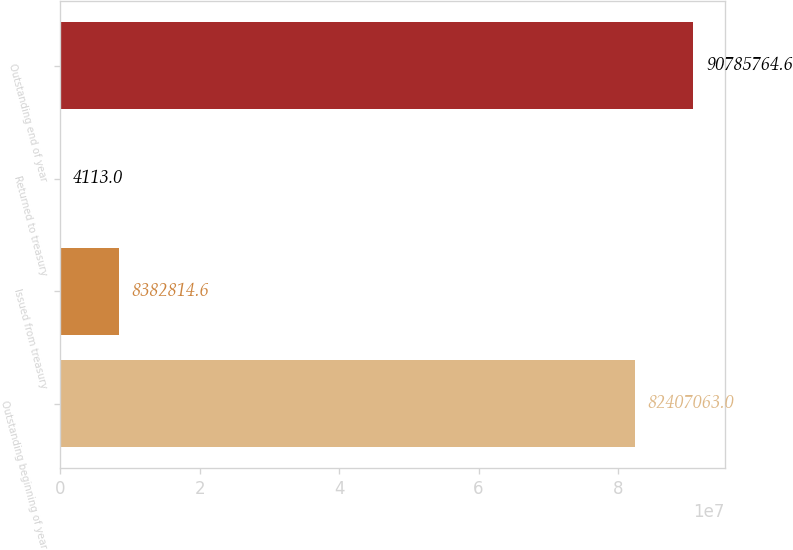Convert chart to OTSL. <chart><loc_0><loc_0><loc_500><loc_500><bar_chart><fcel>Outstanding beginning of year<fcel>Issued from treasury<fcel>Returned to treasury<fcel>Outstanding end of year<nl><fcel>8.24071e+07<fcel>8.38281e+06<fcel>4113<fcel>9.07858e+07<nl></chart> 